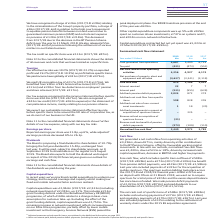According to Bt Group Plc's financial document, What was the net cash inflow from operating activities? According to the financial document, £4,256m. The relevant text states: "ted a net cash inflow from operating activities of £4,256m, down £671m, mainly driven by £2bn contributions to the BT Pension Scheme, offset by favourable wor..." Also, What was the tax benefit from pension deficit payments included in Free Cash Flow? According to the financial document, £273m. The relevant text states: "ific item outflows of £598m (2017/18: £828m) and a £273m (2017/18: £109m) tax benefit from pension deficit payments, was £619m (2017/18: £1,586m). Last year..." Also, What are the years that cash flow details were reported in the table? The document contains multiple relevant values: 2017, 2018, 2019. From the document: "Year ended 31 March 2019 £m 2018 £m 2017 £m Year ended 31 March 2019 £m 2018 £m 2017 £m Year ended 31 March 2019 £m 2018 £m 2017 £m..." Also, can you calculate: What was the change in Cash generated from operations from 2018 to 2019? Based on the calculation: 4,687 - 5,400, the result is -713 (in millions). This is based on the information: "Cash generated from operations 4,687 5,400 6,725 Cash generated from operations 4,687 5,400 6,725..." The key data points involved are: 4,687, 5,400. Also, can you calculate: What is the average tax paid for 2017-2019? To answer this question, I need to perform calculations using the financial data. The calculation is: -(431 + 473 + 551) / 3, which equals -485 (in millions). This is based on the information: "Tax paid (431) (473) (551) Tax paid (431) (473) (551) Tax paid (431) (473) (551)..." The key data points involved are: 431, 473, 551. Also, can you calculate: What is the change in the Net cash inflows from operating activities from 2018 to 2019? Based on the calculation: 4,256 - 4,927, the result is -671 (in millions). This is based on the information: "Net cash inflows from operating activities 4,256 4,927 6,174 Net cash inflows from operating activities 4,256 4,927 6,174..." The key data points involved are: 4,256, 4,927. 